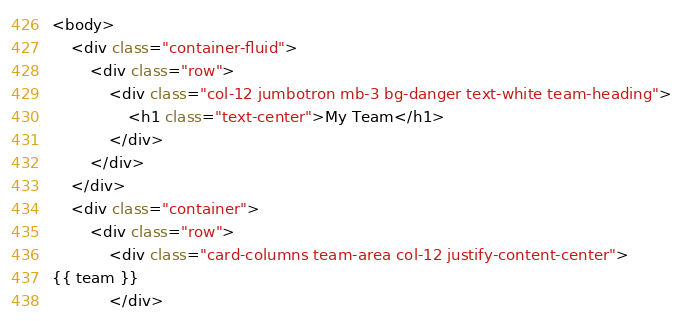<code> <loc_0><loc_0><loc_500><loc_500><_HTML_><body>
    <div class="container-fluid">
        <div class="row">
            <div class="col-12 jumbotron mb-3 bg-danger text-white team-heading">
                <h1 class="text-center">My Team</h1>
            </div>
        </div>
    </div>
    <div class="container">
        <div class="row">
            <div class="card-columns team-area col-12 justify-content-center">
{{ team }}
            </div></code> 